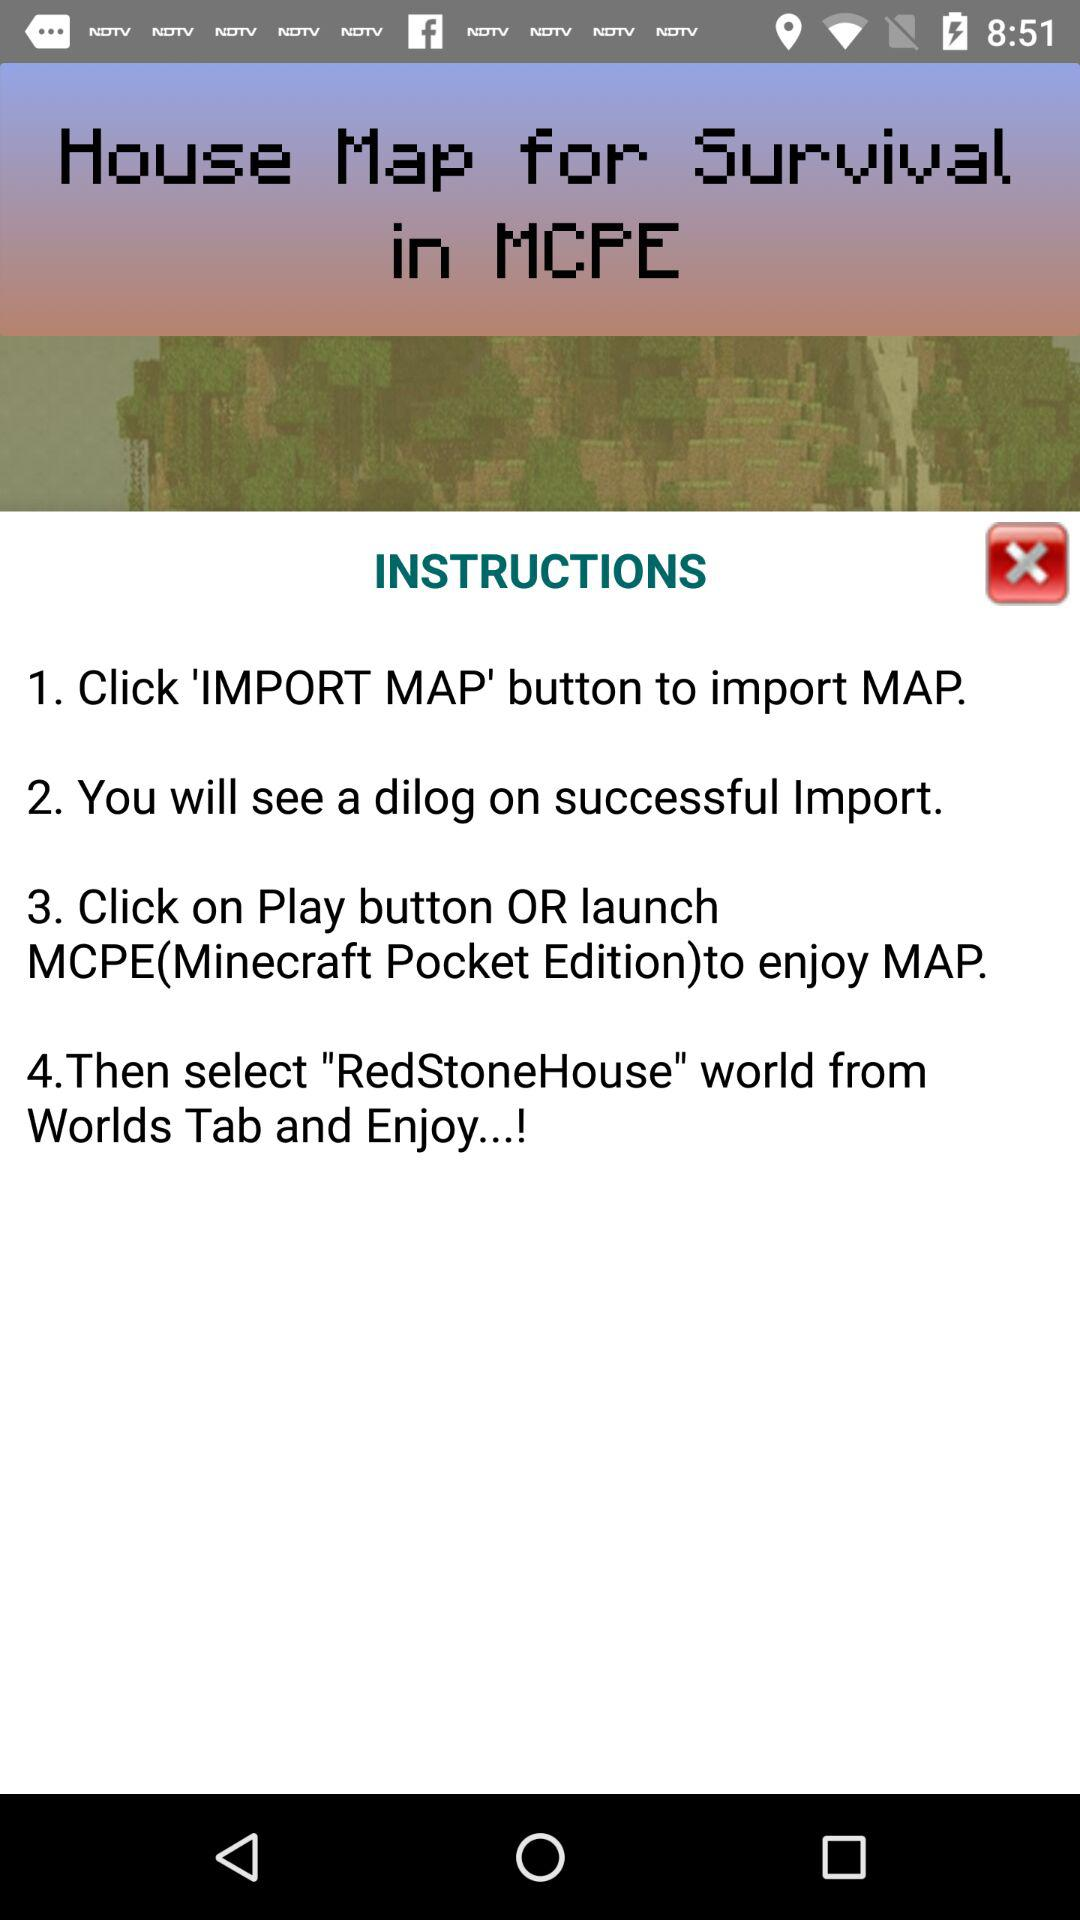Was the "IMPORT MAP" button clicked?
When the provided information is insufficient, respond with <no answer>. <no answer> 